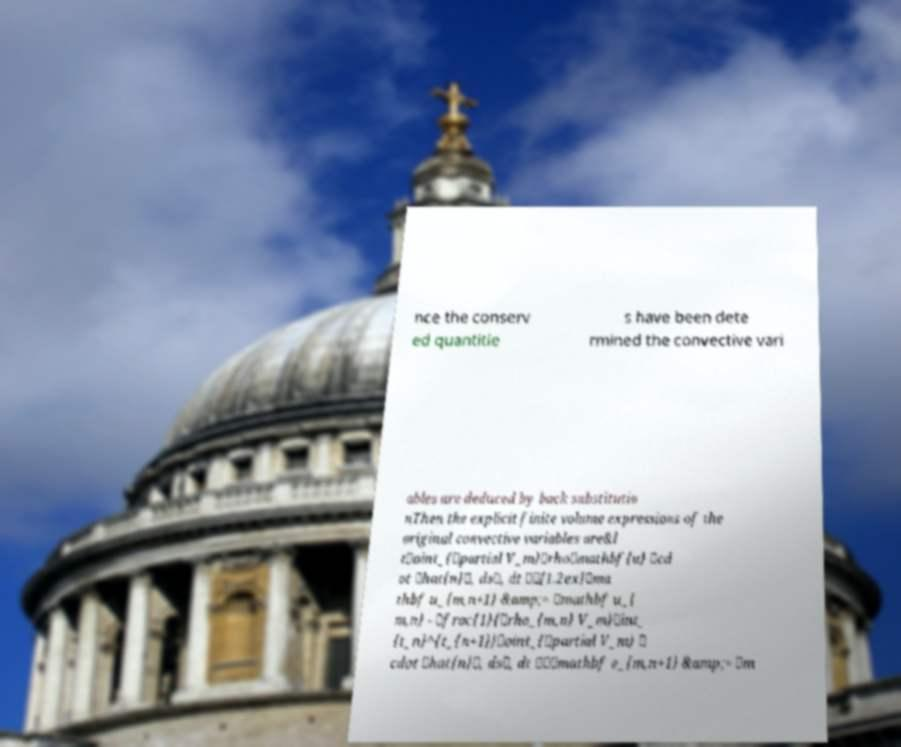Can you read and provide the text displayed in the image?This photo seems to have some interesting text. Can you extract and type it out for me? nce the conserv ed quantitie s have been dete rmined the convective vari ables are deduced by back substitutio nThen the explicit finite volume expressions of the original convective variables are&l t\oint_{\partial V_m}\rho\mathbf{u} \cd ot \hat{n}\, ds\, dt \\[1.2ex]\ma thbf u_{m,n+1} &amp;= \mathbf u_{ m,n} - \frac{1}{\rho_{m,n} V_m}\int_ {t_n}^{t_{n+1}}\oint_{\partial V_m} \ cdot \hat{n}\, ds\, dt \\\mathbf e_{m,n+1} &amp;= \m 